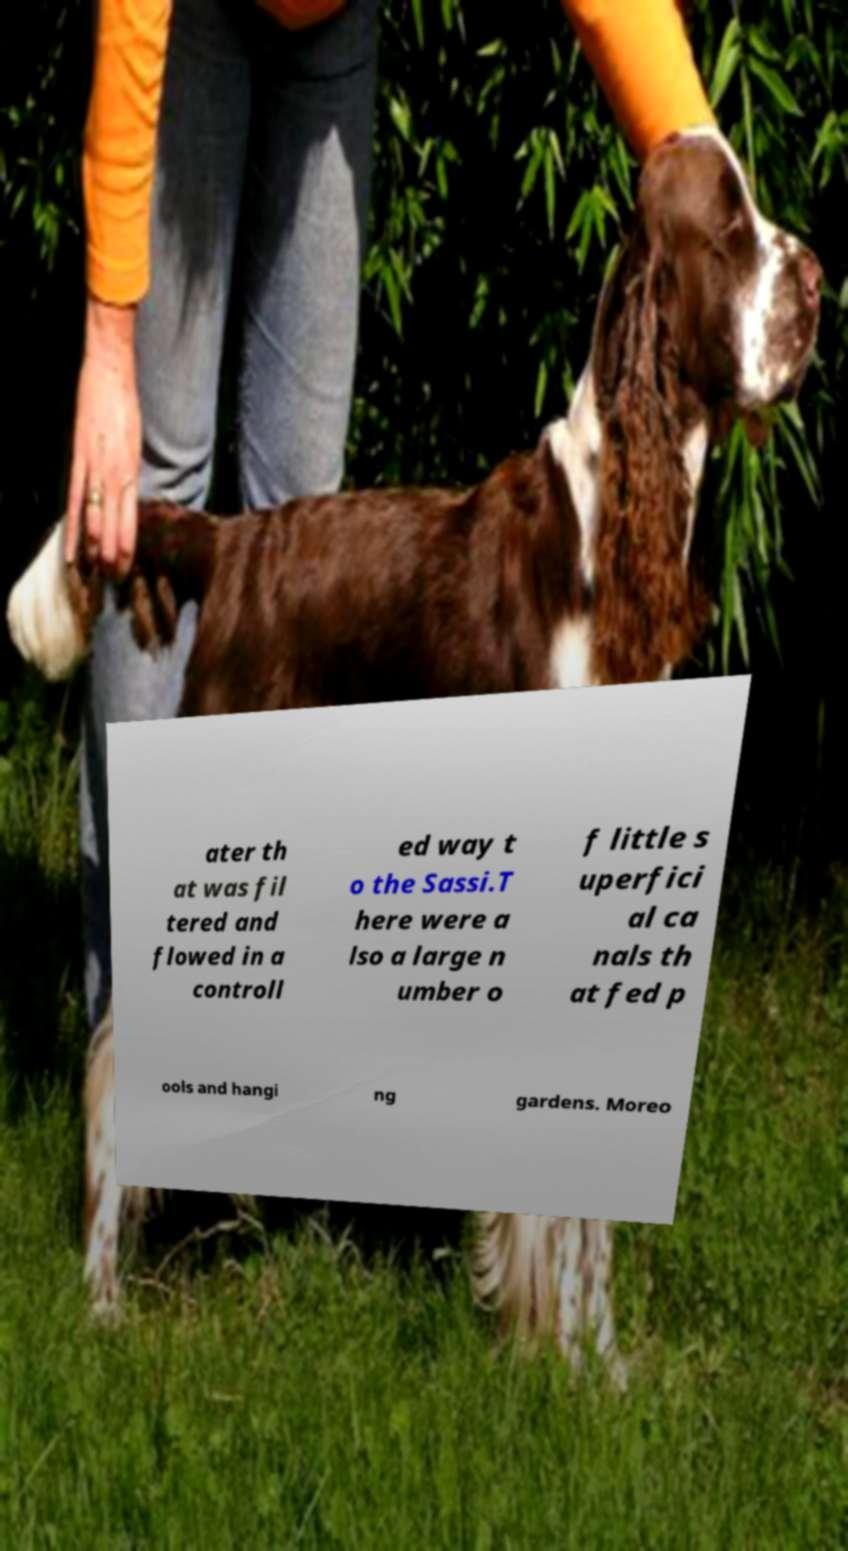Could you extract and type out the text from this image? ater th at was fil tered and flowed in a controll ed way t o the Sassi.T here were a lso a large n umber o f little s uperfici al ca nals th at fed p ools and hangi ng gardens. Moreo 